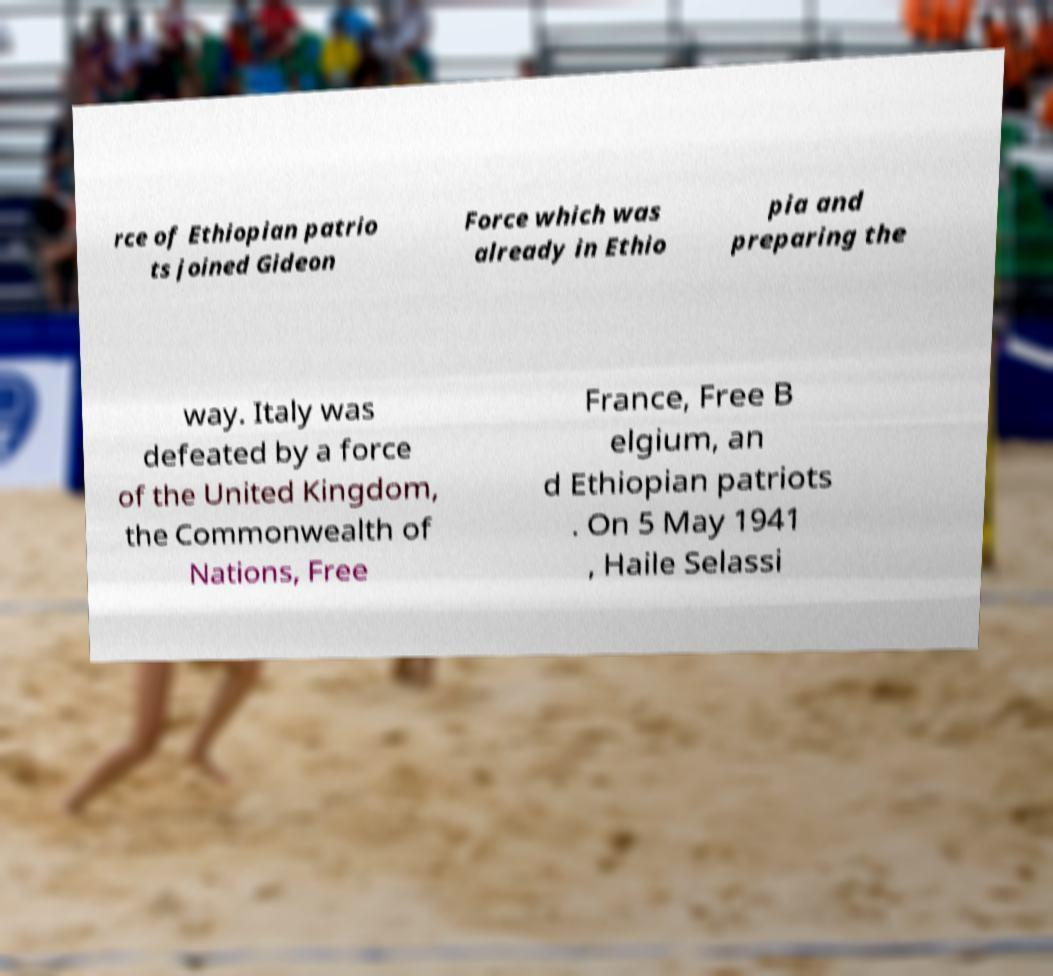For documentation purposes, I need the text within this image transcribed. Could you provide that? rce of Ethiopian patrio ts joined Gideon Force which was already in Ethio pia and preparing the way. Italy was defeated by a force of the United Kingdom, the Commonwealth of Nations, Free France, Free B elgium, an d Ethiopian patriots . On 5 May 1941 , Haile Selassi 